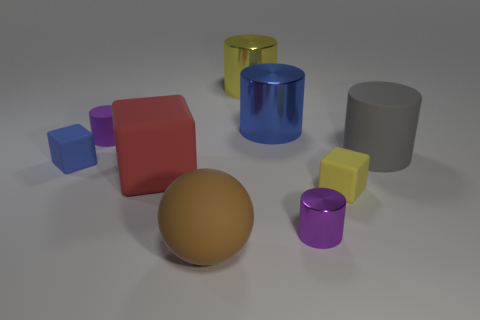Does the gray rubber cylinder have the same size as the purple cylinder in front of the small yellow cube?
Provide a short and direct response. No. Do the blue cube that is left of the red cube and the small cylinder on the left side of the tiny purple metallic cylinder have the same material?
Your response must be concise. Yes. Are there an equal number of big blue metal things in front of the yellow cube and tiny cubes right of the tiny blue matte thing?
Give a very brief answer. No. What number of small matte objects are the same color as the tiny shiny cylinder?
Provide a succinct answer. 1. There is another cylinder that is the same color as the tiny matte cylinder; what is it made of?
Provide a short and direct response. Metal. How many shiny objects are either big cylinders or yellow cylinders?
Keep it short and to the point. 2. Do the metal object on the left side of the blue cylinder and the tiny purple thing behind the large red object have the same shape?
Ensure brevity in your answer.  Yes. What number of brown objects are on the right side of the large red matte cube?
Your answer should be very brief. 1. Is there a big brown thing that has the same material as the big gray cylinder?
Give a very brief answer. Yes. There is a gray object that is the same size as the red matte cube; what is its material?
Your answer should be very brief. Rubber. 